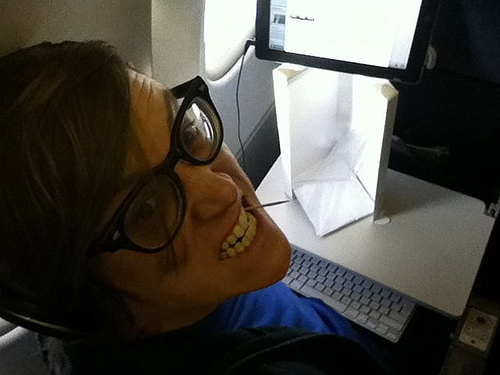Does the guy appear to be enjoying himself? Yes, the guy seems to be enjoying himself, likely engaged in an activity that he finds entertaining or fulfilling. 